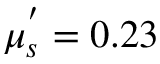Convert formula to latex. <formula><loc_0><loc_0><loc_500><loc_500>\mu _ { s } ^ { ^ { \prime } } = 0 . 2 3</formula> 